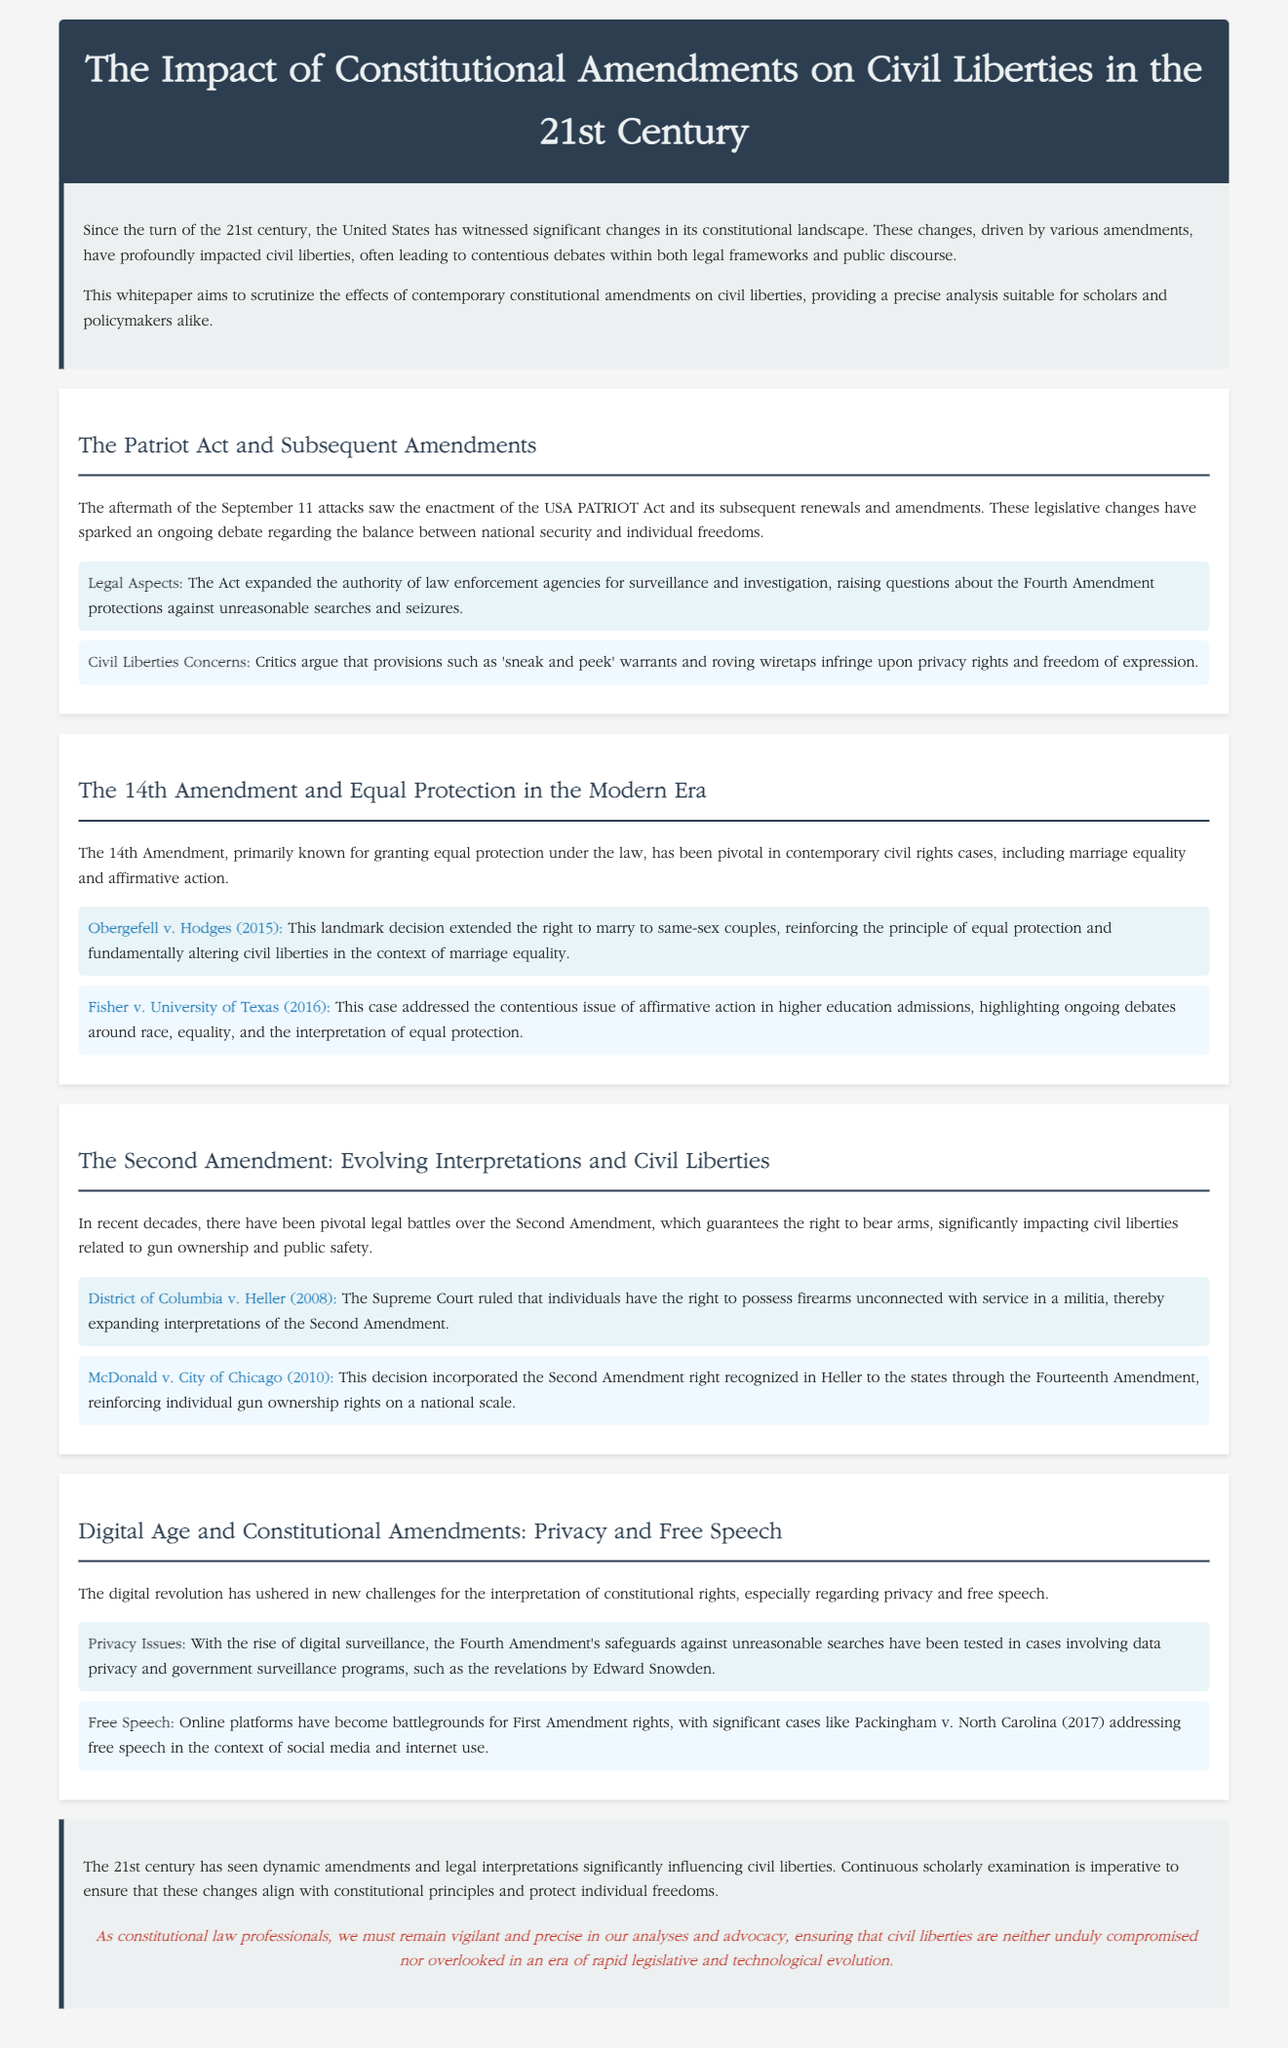What is the title of the whitepaper? The title of the whitepaper is explicitly stated in the header section of the document.
Answer: The Impact of Constitutional Amendments on Civil Liberties in the 21st Century What amendment is primarily discussed regarding equal protection? The document mentions the 14th Amendment in the context of equal protection under the law.
Answer: 14th Amendment Which Supreme Court case legalized same-sex marriage? The case is highlighted in the section discussing the 14th Amendment and is a key point in the analysis.
Answer: Obergefell v. Hodges What year was the USA PATRIOT Act enacted? The document references the enactment of the Act but does not provide a specific year; one must infer it was after September 11, 2001.
Answer: 2001 What significant privacy issue is raised in the context of digital surveillance? The whitepaper discusses how the Fourth Amendment's safeguards against unreasonable searches have been tested due to digital surveillance.
Answer: Privacy Issues Which case addressed free speech on social media? The document specifically mentions this case in the section on the Digital Age and First Amendment rights.
Answer: Packingham v. North Carolina What is a key concern critics have regarding the USA PATRIOT Act? The whitepaper indicates that critics argue certain provisions of the Act infringe upon freedom of expression and privacy rights.
Answer: Civil Liberties Concerns What is the focus of the conclusion in the whitepaper? The conclusion summarizes the dynamic amendments and legal interpretations impacting civil liberties in the 21st century.
Answer: Civil liberties 